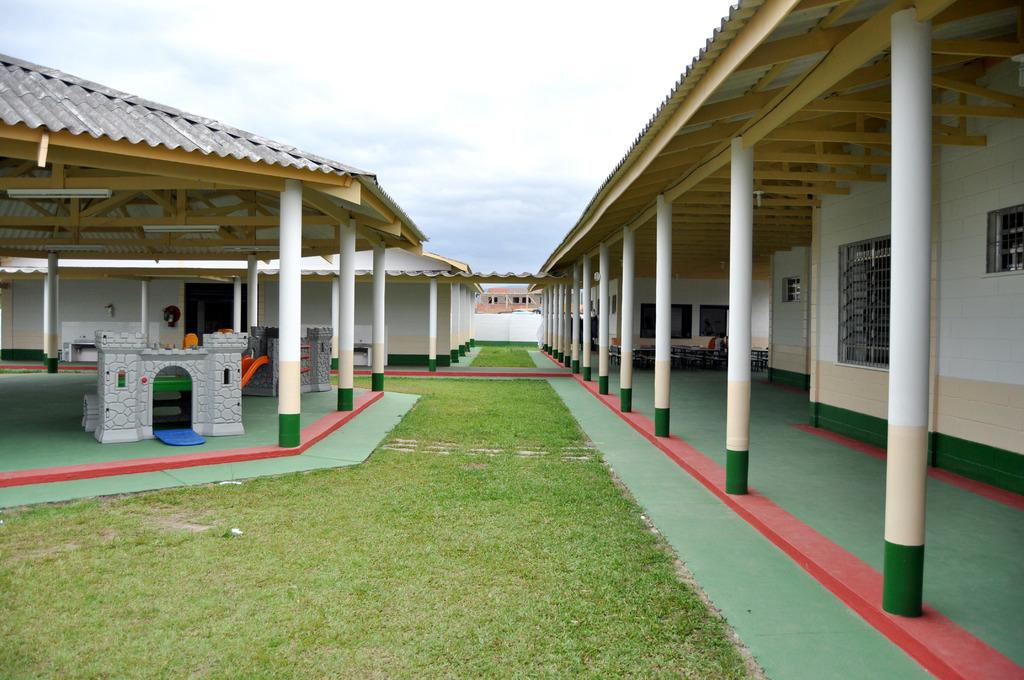What type of structures are present in the image? There are shelters in the image. What are the main features of these shelters? The shelters have pillars and rooms. What is the surrounding area like? The shelters are surrounded by a grass surface. Where is the basin located in the image? There is no basin present in the image. What type of paper can be seen on the walls of the shelters? There is no paper visible on the walls of the shelters in the image. 